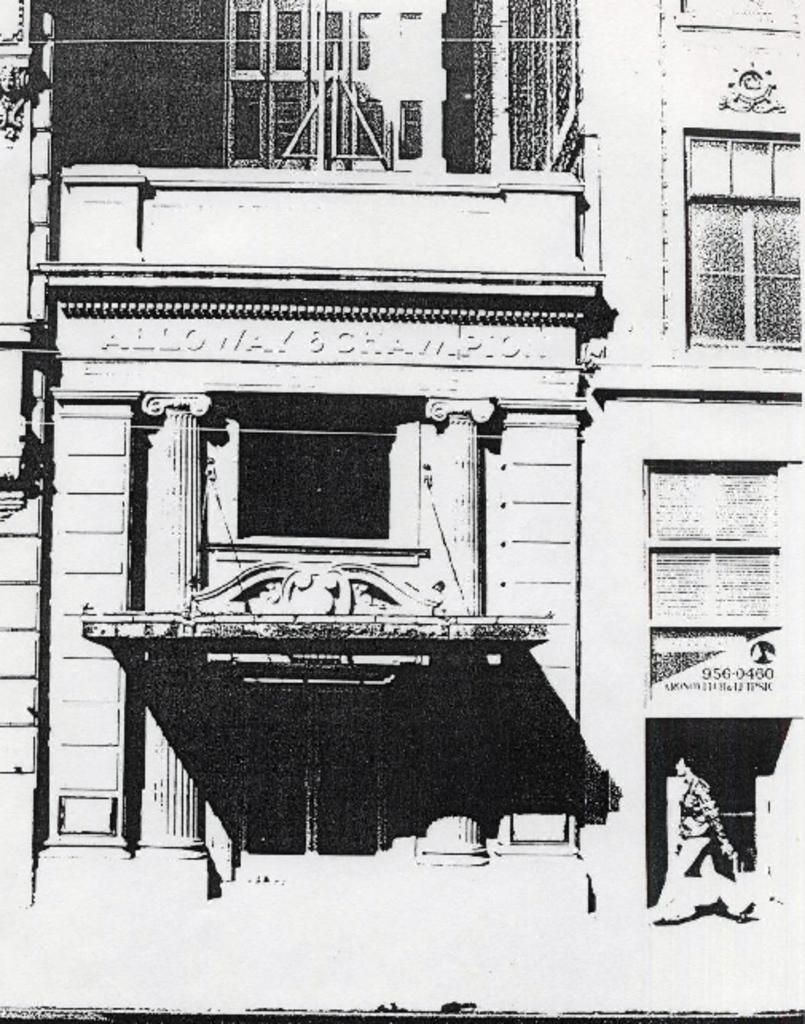Could you give a brief overview of what you see in this image? This is a black and white image. In the image there is a building with walls, windows, roofs and pillars. And also there is name on it. And also there is a person walking. 